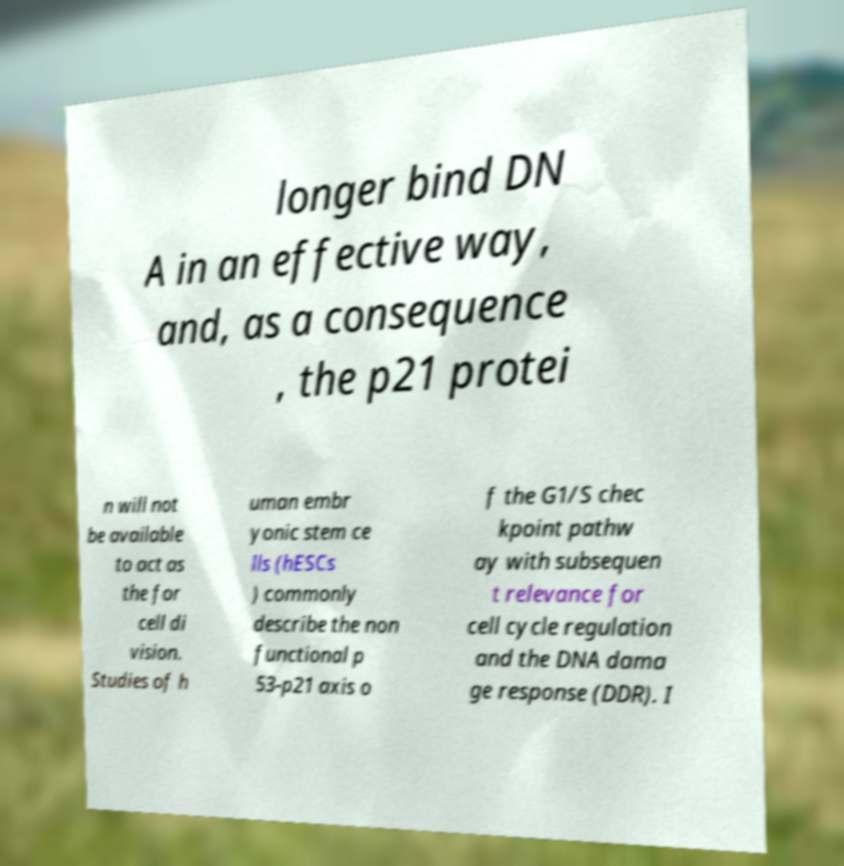What messages or text are displayed in this image? I need them in a readable, typed format. longer bind DN A in an effective way, and, as a consequence , the p21 protei n will not be available to act as the for cell di vision. Studies of h uman embr yonic stem ce lls (hESCs ) commonly describe the non functional p 53-p21 axis o f the G1/S chec kpoint pathw ay with subsequen t relevance for cell cycle regulation and the DNA dama ge response (DDR). I 